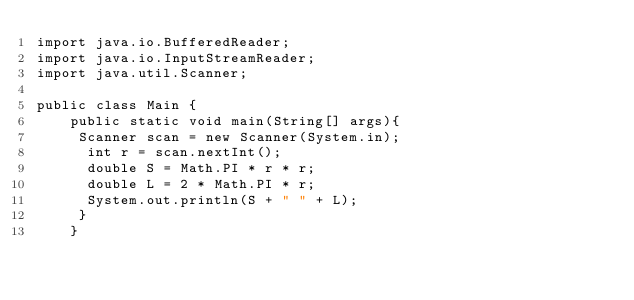Convert code to text. <code><loc_0><loc_0><loc_500><loc_500><_Java_>import java.io.BufferedReader;
import java.io.InputStreamReader;
import java.util.Scanner;

public class Main {
    public static void main(String[] args){
     Scanner scan = new Scanner(System.in);
      int r = scan.nextInt();
      double S = Math.PI * r * r;
      double L = 2 * Math.PI * r;
      System.out.println(S + " " + L);
     }
    }
</code> 